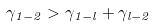Convert formula to latex. <formula><loc_0><loc_0><loc_500><loc_500>\gamma _ { 1 - 2 } > \gamma _ { 1 - l } + \gamma _ { l - 2 }</formula> 